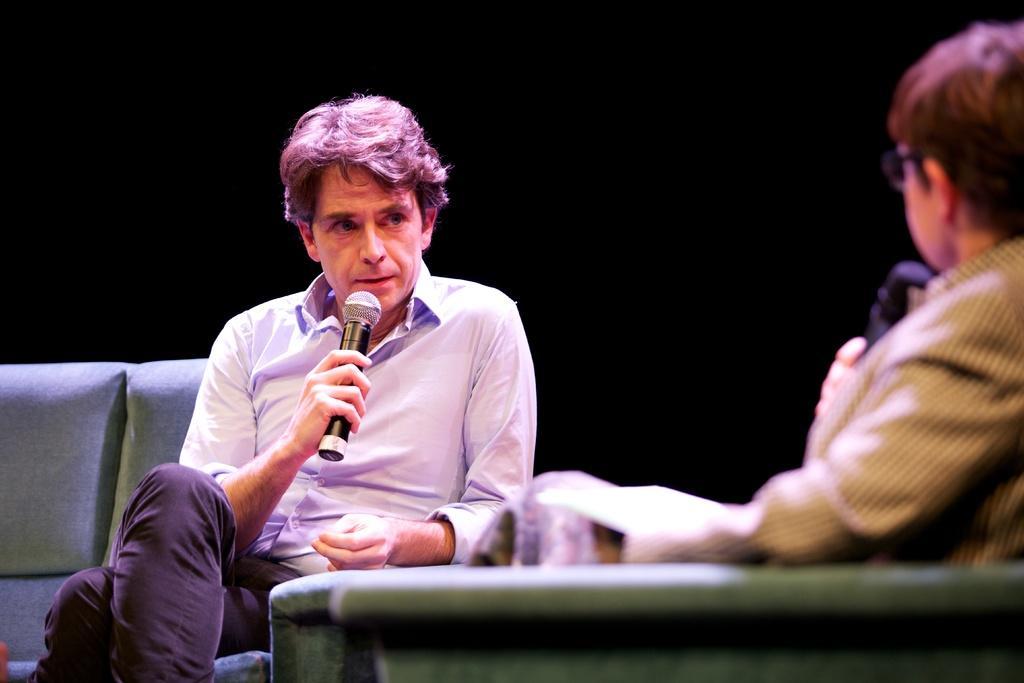Describe this image in one or two sentences. There are two people sitting and holding microphones. We can see sofa and chair. In the background it is dark. 